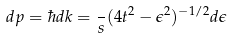<formula> <loc_0><loc_0><loc_500><loc_500>d p = \hbar { d } k = \frac { } { s } ( 4 t ^ { 2 } - \epsilon ^ { 2 } ) ^ { - 1 / 2 } d \epsilon</formula> 